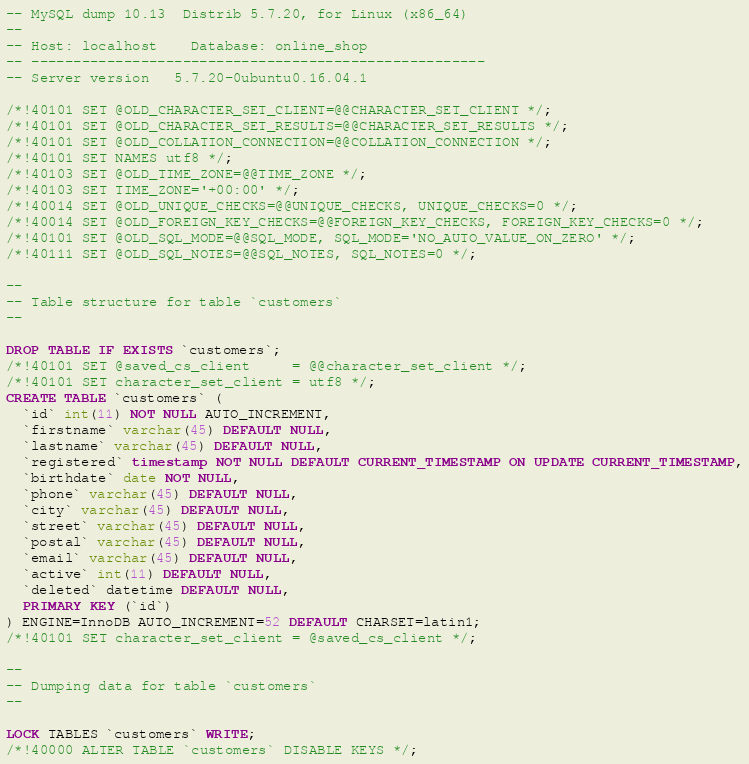Convert code to text. <code><loc_0><loc_0><loc_500><loc_500><_SQL_>-- MySQL dump 10.13  Distrib 5.7.20, for Linux (x86_64)
--
-- Host: localhost    Database: online_shop
-- ------------------------------------------------------
-- Server version	5.7.20-0ubuntu0.16.04.1

/*!40101 SET @OLD_CHARACTER_SET_CLIENT=@@CHARACTER_SET_CLIENT */;
/*!40101 SET @OLD_CHARACTER_SET_RESULTS=@@CHARACTER_SET_RESULTS */;
/*!40101 SET @OLD_COLLATION_CONNECTION=@@COLLATION_CONNECTION */;
/*!40101 SET NAMES utf8 */;
/*!40103 SET @OLD_TIME_ZONE=@@TIME_ZONE */;
/*!40103 SET TIME_ZONE='+00:00' */;
/*!40014 SET @OLD_UNIQUE_CHECKS=@@UNIQUE_CHECKS, UNIQUE_CHECKS=0 */;
/*!40014 SET @OLD_FOREIGN_KEY_CHECKS=@@FOREIGN_KEY_CHECKS, FOREIGN_KEY_CHECKS=0 */;
/*!40101 SET @OLD_SQL_MODE=@@SQL_MODE, SQL_MODE='NO_AUTO_VALUE_ON_ZERO' */;
/*!40111 SET @OLD_SQL_NOTES=@@SQL_NOTES, SQL_NOTES=0 */;

--
-- Table structure for table `customers`
--

DROP TABLE IF EXISTS `customers`;
/*!40101 SET @saved_cs_client     = @@character_set_client */;
/*!40101 SET character_set_client = utf8 */;
CREATE TABLE `customers` (
  `id` int(11) NOT NULL AUTO_INCREMENT,
  `firstname` varchar(45) DEFAULT NULL,
  `lastname` varchar(45) DEFAULT NULL,
  `registered` timestamp NOT NULL DEFAULT CURRENT_TIMESTAMP ON UPDATE CURRENT_TIMESTAMP,
  `birthdate` date NOT NULL,
  `phone` varchar(45) DEFAULT NULL,
  `city` varchar(45) DEFAULT NULL,
  `street` varchar(45) DEFAULT NULL,
  `postal` varchar(45) DEFAULT NULL,
  `email` varchar(45) DEFAULT NULL,
  `active` int(11) DEFAULT NULL,
  `deleted` datetime DEFAULT NULL,
  PRIMARY KEY (`id`)
) ENGINE=InnoDB AUTO_INCREMENT=52 DEFAULT CHARSET=latin1;
/*!40101 SET character_set_client = @saved_cs_client */;

--
-- Dumping data for table `customers`
--

LOCK TABLES `customers` WRITE;
/*!40000 ALTER TABLE `customers` DISABLE KEYS */;</code> 